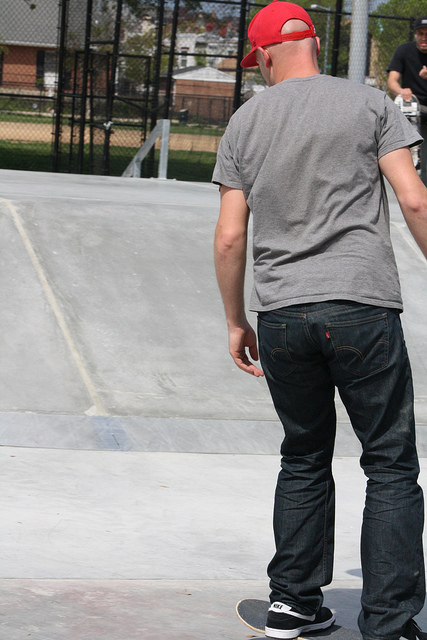<image>What kind of league does he play for? It is impossible to determine what kind of league he plays for. It could be skateboarding or baseball. What sport is this figure from? I am not sure what sport is this figure from. But, mostly, it seems to be from skateboarding. What kind of league does he play for? I don't know what kind of league he plays for. It is impossible to determine from the given options. What sport is this figure from? I don't know what sport this figure is from. It can be seen as skateboarding or baseball. 